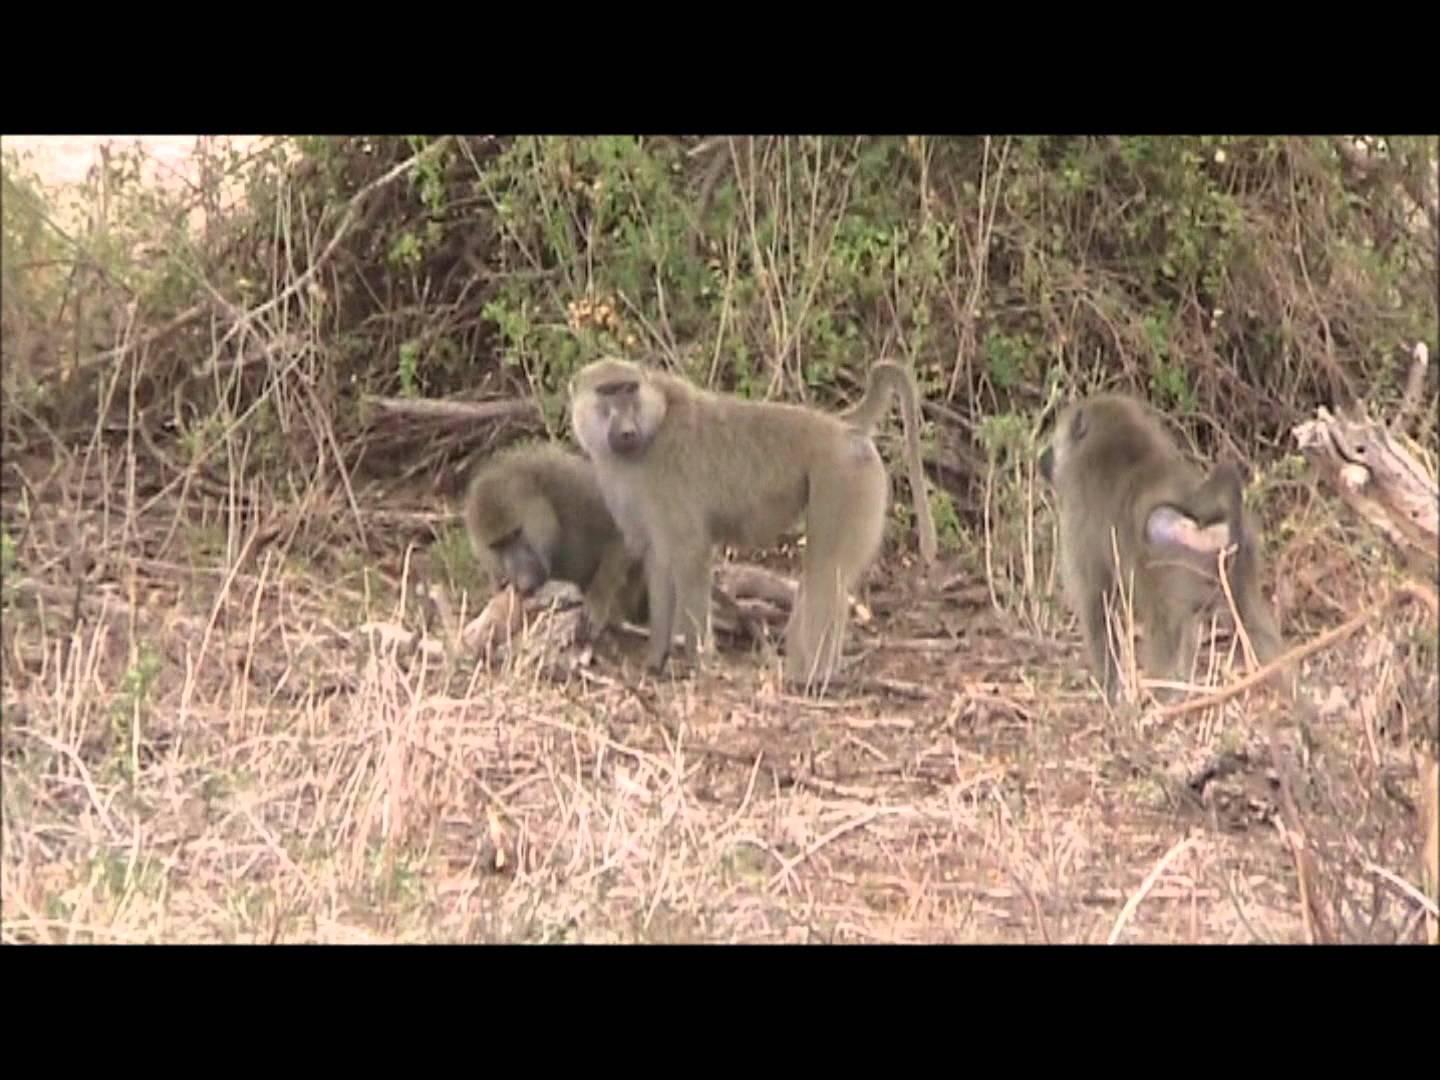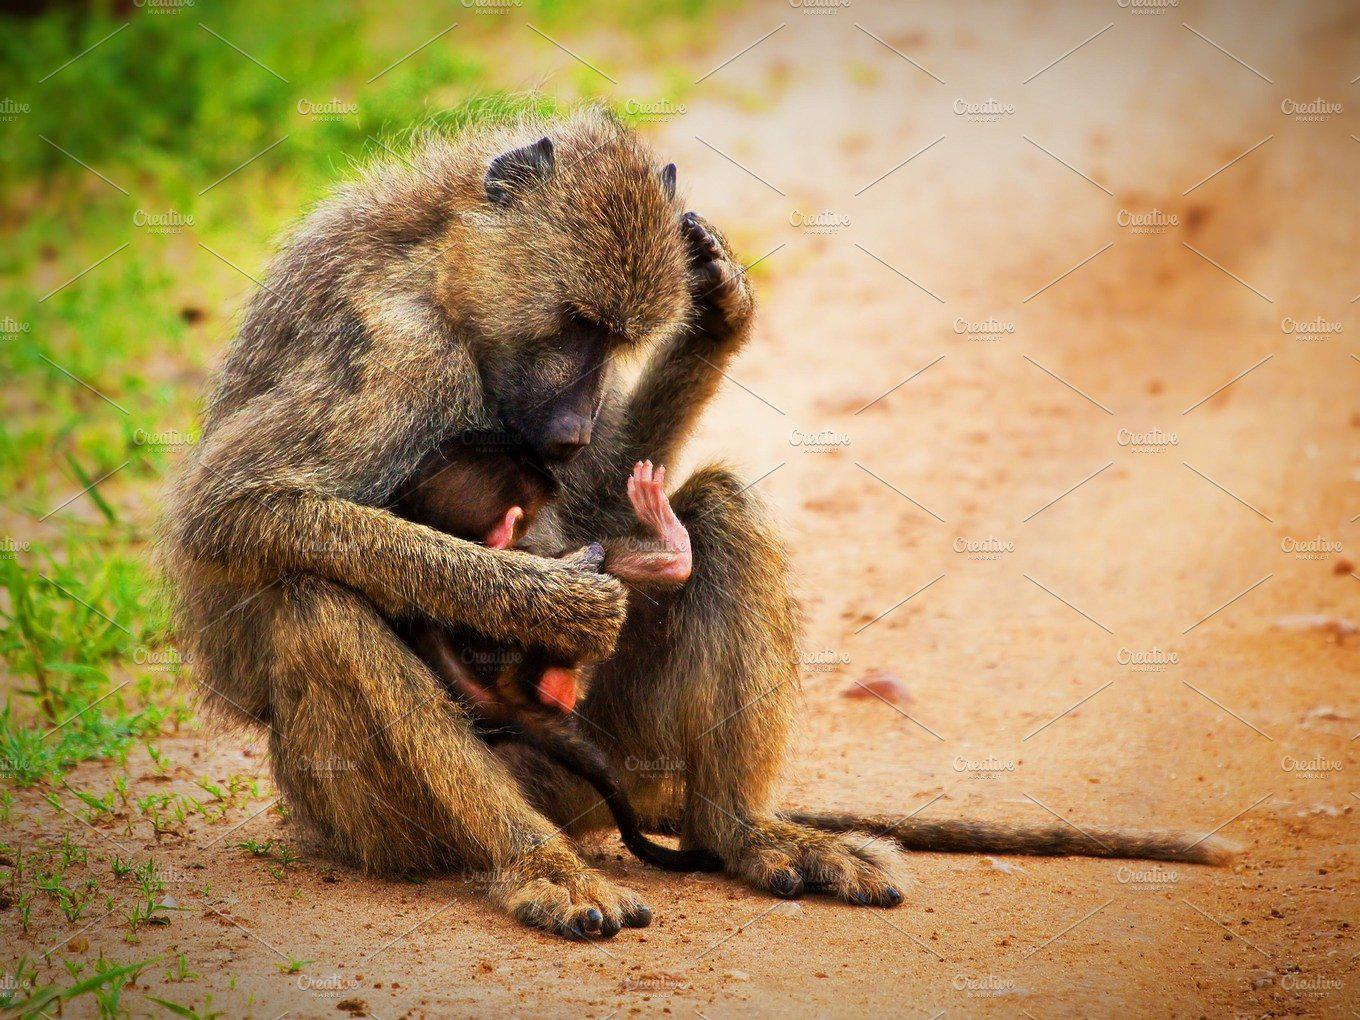The first image is the image on the left, the second image is the image on the right. For the images displayed, is the sentence "An image show a right-facing monkey with wide-opened mouth baring its fangs." factually correct? Answer yes or no. No. The first image is the image on the left, the second image is the image on the right. Assess this claim about the two images: "At least one monkey has its mouth wide open with sharp teeth visible.". Correct or not? Answer yes or no. No. 